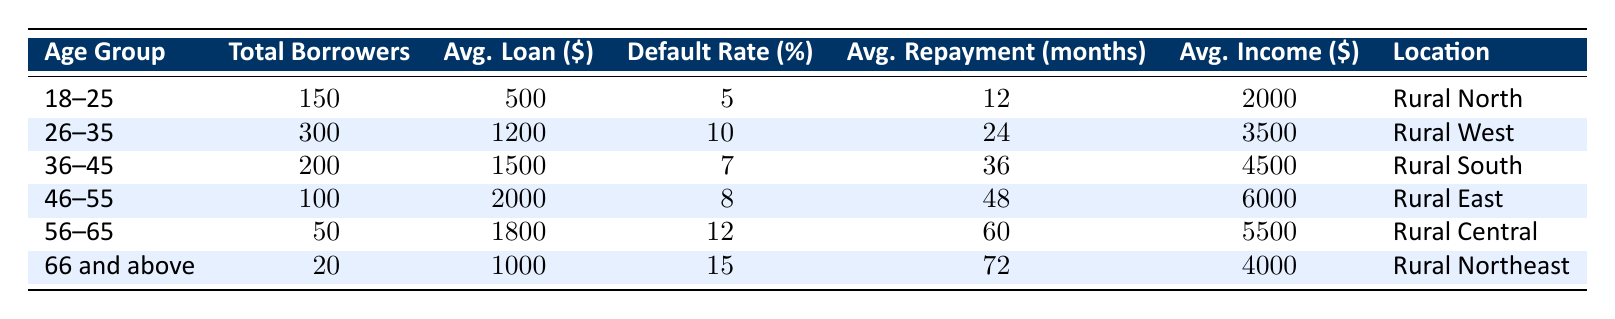What is the total number of borrowers in the 36-45 age group? The table indicates that the total number of borrowers in the 36-45 age group is directly stated as 200.
Answer: 200 What is the average loan amount for borrowers aged 46-55? According to the table, the average loan amount for the 46-55 age group is listed as $2,000.
Answer: 2000 What age group has the highest default rate? By comparing the default rates across all age groups in the table, the 66 and above group has the highest default rate at 15%.
Answer: 66 and above What is the average repayment period for the 56-65 age group? The table shows that the average repayment period for this age group is 60 months.
Answer: 60 months What is the total income of all borrowers aged 26-35? The average income for this age group is $3,500, and there are 300 borrowers. Therefore, total income is calculated as 300 * 3500, which equals $1,050,000.
Answer: 1,050,000 Which age group has the highest average income, and what is that amount? When looking at the average income column, it shows that the 46-55 age group has the highest average income at $6,000.
Answer: 46-55, 6000 If we combine the total borrowers from both the 18-25 and 26-35 age groups, what is the total? The total borrowers in the 18-25 group are 150, and in the 26-35 group are 300. Adding these together results in 150 + 300 = 450 total borrowers.
Answer: 450 What is the difference in average loan amounts between the 36-45 age group and the 56-65 age group? The average loan amount for the 36-45 age group is $1,500 and for 56-65 is $1,800. The difference is calculated as 1,800 - 1,500 = $300.
Answer: 300 Are there more borrowers in the 46-55 age group than in the 66 and above age group? The table states that there are 100 borrowers in the 46-55 age group and 20 in the 66 and above group. Since 100 is greater than 20, the statement is true.
Answer: Yes What is the average loan amount for borrowers in all age groups combined? To find the average loan amount, we take the total loan amounts (500, 1200, 1500, 2000, 1800, 1000) for the respective groups multiplied by their borrowers: (150*500 + 300*1200 + 200*1500 + 100*2000 + 50*1800 + 20*1000) = 75000 + 360000 + 300000 + 200000 + 90000 + 20000 = 1220000. There are 1,120 total borrowers: 1120000 / 1120 = approx. $1,089.29.
Answer: Approximately 1089.29 